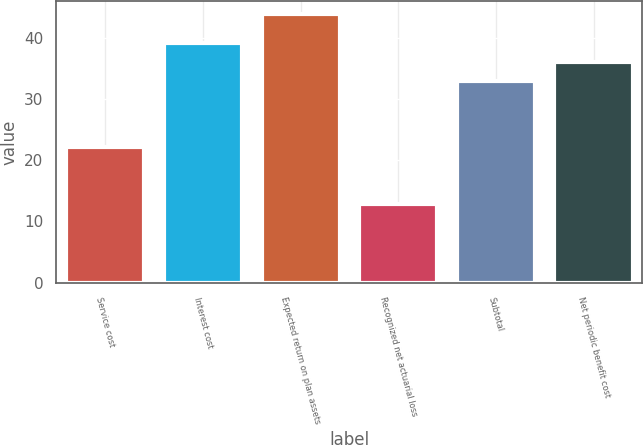Convert chart. <chart><loc_0><loc_0><loc_500><loc_500><bar_chart><fcel>Service cost<fcel>Interest cost<fcel>Expected return on plan assets<fcel>Recognized net actuarial loss<fcel>Subtotal<fcel>Net periodic benefit cost<nl><fcel>22.1<fcel>39.18<fcel>43.8<fcel>12.9<fcel>33<fcel>36.09<nl></chart> 